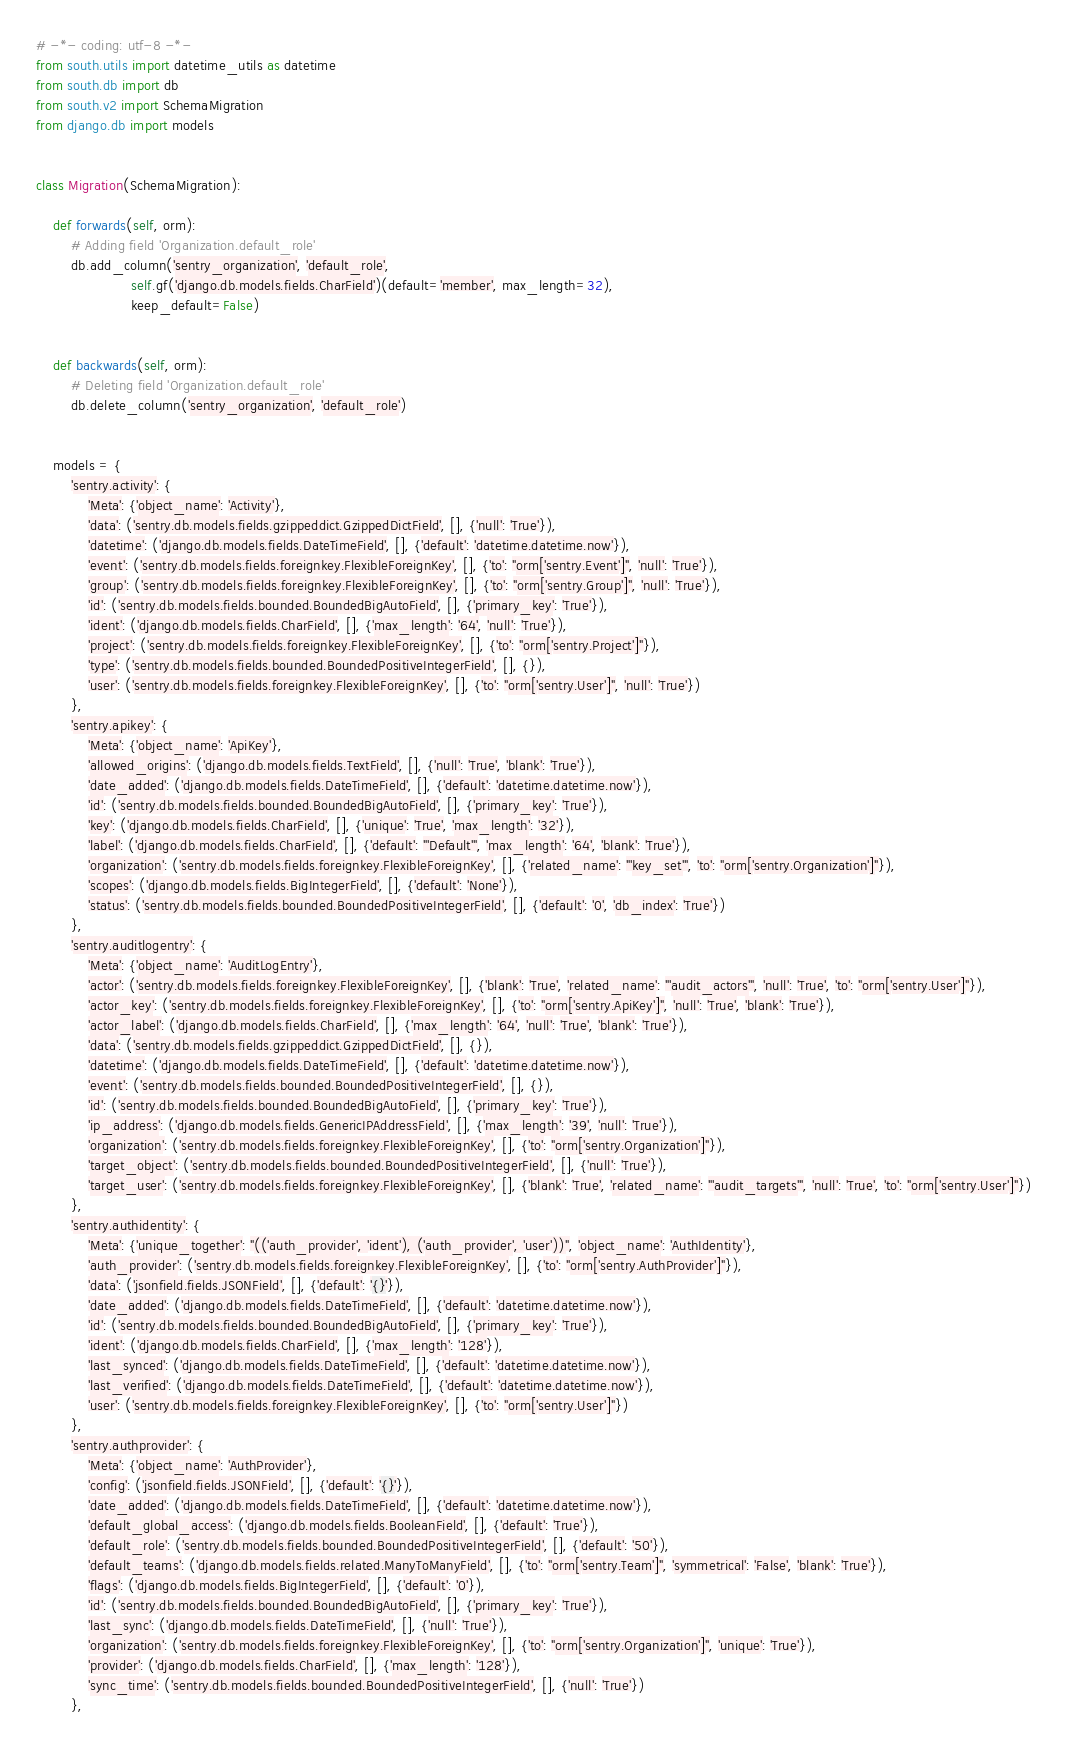Convert code to text. <code><loc_0><loc_0><loc_500><loc_500><_Python_># -*- coding: utf-8 -*-
from south.utils import datetime_utils as datetime
from south.db import db
from south.v2 import SchemaMigration
from django.db import models


class Migration(SchemaMigration):

    def forwards(self, orm):
        # Adding field 'Organization.default_role'
        db.add_column('sentry_organization', 'default_role',
                      self.gf('django.db.models.fields.CharField')(default='member', max_length=32),
                      keep_default=False)


    def backwards(self, orm):
        # Deleting field 'Organization.default_role'
        db.delete_column('sentry_organization', 'default_role')


    models = {
        'sentry.activity': {
            'Meta': {'object_name': 'Activity'},
            'data': ('sentry.db.models.fields.gzippeddict.GzippedDictField', [], {'null': 'True'}),
            'datetime': ('django.db.models.fields.DateTimeField', [], {'default': 'datetime.datetime.now'}),
            'event': ('sentry.db.models.fields.foreignkey.FlexibleForeignKey', [], {'to': "orm['sentry.Event']", 'null': 'True'}),
            'group': ('sentry.db.models.fields.foreignkey.FlexibleForeignKey', [], {'to': "orm['sentry.Group']", 'null': 'True'}),
            'id': ('sentry.db.models.fields.bounded.BoundedBigAutoField', [], {'primary_key': 'True'}),
            'ident': ('django.db.models.fields.CharField', [], {'max_length': '64', 'null': 'True'}),
            'project': ('sentry.db.models.fields.foreignkey.FlexibleForeignKey', [], {'to': "orm['sentry.Project']"}),
            'type': ('sentry.db.models.fields.bounded.BoundedPositiveIntegerField', [], {}),
            'user': ('sentry.db.models.fields.foreignkey.FlexibleForeignKey', [], {'to': "orm['sentry.User']", 'null': 'True'})
        },
        'sentry.apikey': {
            'Meta': {'object_name': 'ApiKey'},
            'allowed_origins': ('django.db.models.fields.TextField', [], {'null': 'True', 'blank': 'True'}),
            'date_added': ('django.db.models.fields.DateTimeField', [], {'default': 'datetime.datetime.now'}),
            'id': ('sentry.db.models.fields.bounded.BoundedBigAutoField', [], {'primary_key': 'True'}),
            'key': ('django.db.models.fields.CharField', [], {'unique': 'True', 'max_length': '32'}),
            'label': ('django.db.models.fields.CharField', [], {'default': "'Default'", 'max_length': '64', 'blank': 'True'}),
            'organization': ('sentry.db.models.fields.foreignkey.FlexibleForeignKey', [], {'related_name': "'key_set'", 'to': "orm['sentry.Organization']"}),
            'scopes': ('django.db.models.fields.BigIntegerField', [], {'default': 'None'}),
            'status': ('sentry.db.models.fields.bounded.BoundedPositiveIntegerField', [], {'default': '0', 'db_index': 'True'})
        },
        'sentry.auditlogentry': {
            'Meta': {'object_name': 'AuditLogEntry'},
            'actor': ('sentry.db.models.fields.foreignkey.FlexibleForeignKey', [], {'blank': 'True', 'related_name': "'audit_actors'", 'null': 'True', 'to': "orm['sentry.User']"}),
            'actor_key': ('sentry.db.models.fields.foreignkey.FlexibleForeignKey', [], {'to': "orm['sentry.ApiKey']", 'null': 'True', 'blank': 'True'}),
            'actor_label': ('django.db.models.fields.CharField', [], {'max_length': '64', 'null': 'True', 'blank': 'True'}),
            'data': ('sentry.db.models.fields.gzippeddict.GzippedDictField', [], {}),
            'datetime': ('django.db.models.fields.DateTimeField', [], {'default': 'datetime.datetime.now'}),
            'event': ('sentry.db.models.fields.bounded.BoundedPositiveIntegerField', [], {}),
            'id': ('sentry.db.models.fields.bounded.BoundedBigAutoField', [], {'primary_key': 'True'}),
            'ip_address': ('django.db.models.fields.GenericIPAddressField', [], {'max_length': '39', 'null': 'True'}),
            'organization': ('sentry.db.models.fields.foreignkey.FlexibleForeignKey', [], {'to': "orm['sentry.Organization']"}),
            'target_object': ('sentry.db.models.fields.bounded.BoundedPositiveIntegerField', [], {'null': 'True'}),
            'target_user': ('sentry.db.models.fields.foreignkey.FlexibleForeignKey', [], {'blank': 'True', 'related_name': "'audit_targets'", 'null': 'True', 'to': "orm['sentry.User']"})
        },
        'sentry.authidentity': {
            'Meta': {'unique_together': "(('auth_provider', 'ident'), ('auth_provider', 'user'))", 'object_name': 'AuthIdentity'},
            'auth_provider': ('sentry.db.models.fields.foreignkey.FlexibleForeignKey', [], {'to': "orm['sentry.AuthProvider']"}),
            'data': ('jsonfield.fields.JSONField', [], {'default': '{}'}),
            'date_added': ('django.db.models.fields.DateTimeField', [], {'default': 'datetime.datetime.now'}),
            'id': ('sentry.db.models.fields.bounded.BoundedBigAutoField', [], {'primary_key': 'True'}),
            'ident': ('django.db.models.fields.CharField', [], {'max_length': '128'}),
            'last_synced': ('django.db.models.fields.DateTimeField', [], {'default': 'datetime.datetime.now'}),
            'last_verified': ('django.db.models.fields.DateTimeField', [], {'default': 'datetime.datetime.now'}),
            'user': ('sentry.db.models.fields.foreignkey.FlexibleForeignKey', [], {'to': "orm['sentry.User']"})
        },
        'sentry.authprovider': {
            'Meta': {'object_name': 'AuthProvider'},
            'config': ('jsonfield.fields.JSONField', [], {'default': '{}'}),
            'date_added': ('django.db.models.fields.DateTimeField', [], {'default': 'datetime.datetime.now'}),
            'default_global_access': ('django.db.models.fields.BooleanField', [], {'default': 'True'}),
            'default_role': ('sentry.db.models.fields.bounded.BoundedPositiveIntegerField', [], {'default': '50'}),
            'default_teams': ('django.db.models.fields.related.ManyToManyField', [], {'to': "orm['sentry.Team']", 'symmetrical': 'False', 'blank': 'True'}),
            'flags': ('django.db.models.fields.BigIntegerField', [], {'default': '0'}),
            'id': ('sentry.db.models.fields.bounded.BoundedBigAutoField', [], {'primary_key': 'True'}),
            'last_sync': ('django.db.models.fields.DateTimeField', [], {'null': 'True'}),
            'organization': ('sentry.db.models.fields.foreignkey.FlexibleForeignKey', [], {'to': "orm['sentry.Organization']", 'unique': 'True'}),
            'provider': ('django.db.models.fields.CharField', [], {'max_length': '128'}),
            'sync_time': ('sentry.db.models.fields.bounded.BoundedPositiveIntegerField', [], {'null': 'True'})
        },</code> 